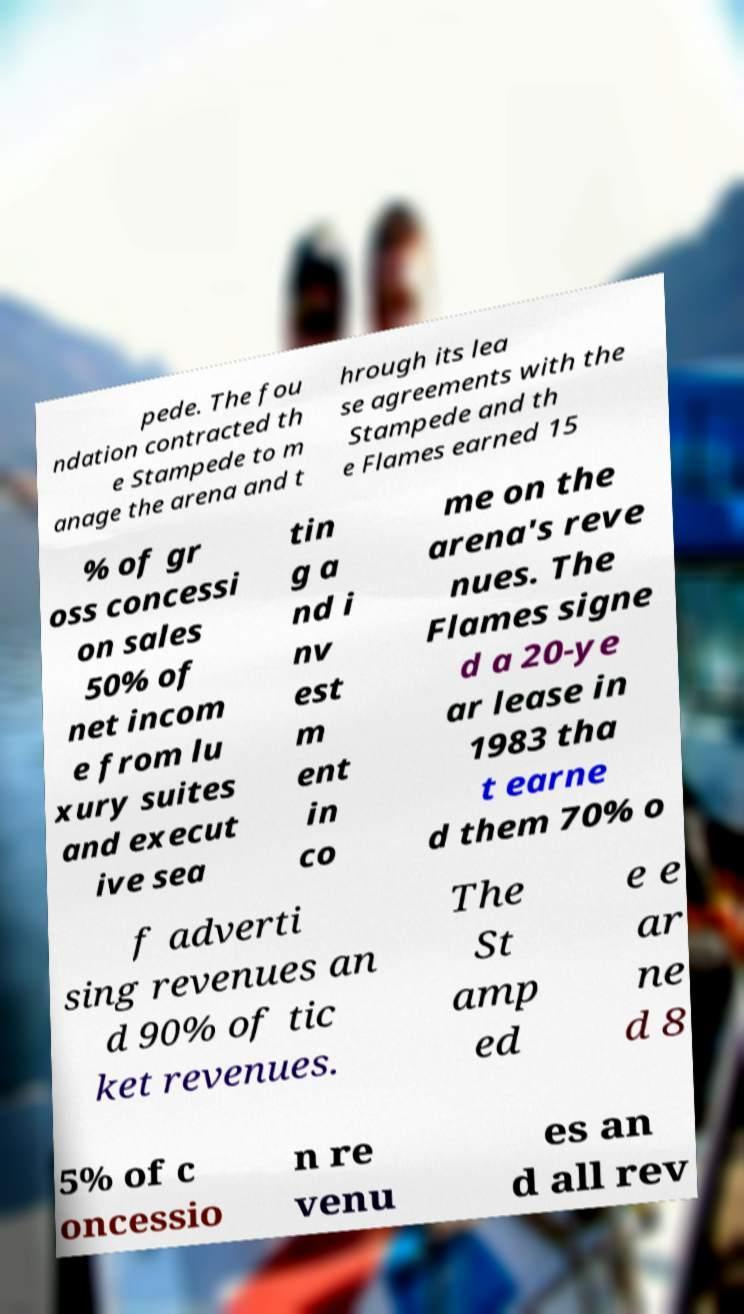Please identify and transcribe the text found in this image. pede. The fou ndation contracted th e Stampede to m anage the arena and t hrough its lea se agreements with the Stampede and th e Flames earned 15 % of gr oss concessi on sales 50% of net incom e from lu xury suites and execut ive sea tin g a nd i nv est m ent in co me on the arena's reve nues. The Flames signe d a 20-ye ar lease in 1983 tha t earne d them 70% o f adverti sing revenues an d 90% of tic ket revenues. The St amp ed e e ar ne d 8 5% of c oncessio n re venu es an d all rev 